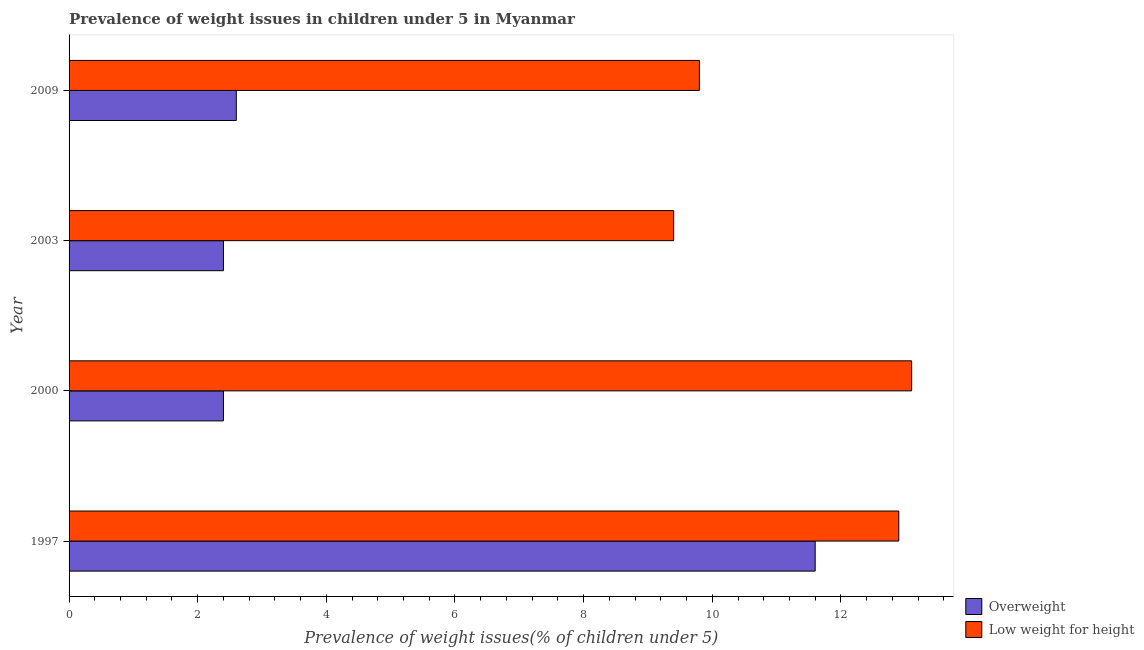How many different coloured bars are there?
Ensure brevity in your answer.  2. How many groups of bars are there?
Your response must be concise. 4. What is the label of the 4th group of bars from the top?
Keep it short and to the point. 1997. In how many cases, is the number of bars for a given year not equal to the number of legend labels?
Provide a short and direct response. 0. What is the percentage of underweight children in 2009?
Offer a very short reply. 9.8. Across all years, what is the maximum percentage of underweight children?
Your answer should be very brief. 13.1. Across all years, what is the minimum percentage of underweight children?
Make the answer very short. 9.4. In which year was the percentage of underweight children minimum?
Provide a succinct answer. 2003. What is the total percentage of overweight children in the graph?
Offer a terse response. 19. What is the difference between the percentage of overweight children in 2003 and the percentage of underweight children in 1997?
Provide a short and direct response. -10.5. What is the ratio of the percentage of underweight children in 1997 to that in 2009?
Give a very brief answer. 1.32. In how many years, is the percentage of underweight children greater than the average percentage of underweight children taken over all years?
Ensure brevity in your answer.  2. What does the 1st bar from the top in 2000 represents?
Your answer should be very brief. Low weight for height. What does the 1st bar from the bottom in 2000 represents?
Give a very brief answer. Overweight. Are all the bars in the graph horizontal?
Keep it short and to the point. Yes. Does the graph contain grids?
Your answer should be compact. No. What is the title of the graph?
Keep it short and to the point. Prevalence of weight issues in children under 5 in Myanmar. What is the label or title of the X-axis?
Your response must be concise. Prevalence of weight issues(% of children under 5). What is the label or title of the Y-axis?
Ensure brevity in your answer.  Year. What is the Prevalence of weight issues(% of children under 5) of Overweight in 1997?
Provide a succinct answer. 11.6. What is the Prevalence of weight issues(% of children under 5) of Low weight for height in 1997?
Give a very brief answer. 12.9. What is the Prevalence of weight issues(% of children under 5) of Overweight in 2000?
Your response must be concise. 2.4. What is the Prevalence of weight issues(% of children under 5) of Low weight for height in 2000?
Offer a very short reply. 13.1. What is the Prevalence of weight issues(% of children under 5) in Overweight in 2003?
Keep it short and to the point. 2.4. What is the Prevalence of weight issues(% of children under 5) of Low weight for height in 2003?
Ensure brevity in your answer.  9.4. What is the Prevalence of weight issues(% of children under 5) in Overweight in 2009?
Make the answer very short. 2.6. What is the Prevalence of weight issues(% of children under 5) in Low weight for height in 2009?
Provide a succinct answer. 9.8. Across all years, what is the maximum Prevalence of weight issues(% of children under 5) of Overweight?
Your answer should be compact. 11.6. Across all years, what is the maximum Prevalence of weight issues(% of children under 5) of Low weight for height?
Provide a short and direct response. 13.1. Across all years, what is the minimum Prevalence of weight issues(% of children under 5) in Overweight?
Your answer should be very brief. 2.4. Across all years, what is the minimum Prevalence of weight issues(% of children under 5) in Low weight for height?
Offer a very short reply. 9.4. What is the total Prevalence of weight issues(% of children under 5) in Overweight in the graph?
Your response must be concise. 19. What is the total Prevalence of weight issues(% of children under 5) in Low weight for height in the graph?
Ensure brevity in your answer.  45.2. What is the difference between the Prevalence of weight issues(% of children under 5) in Low weight for height in 1997 and that in 2003?
Keep it short and to the point. 3.5. What is the difference between the Prevalence of weight issues(% of children under 5) of Overweight in 1997 and that in 2009?
Your response must be concise. 9. What is the difference between the Prevalence of weight issues(% of children under 5) of Low weight for height in 1997 and that in 2009?
Offer a very short reply. 3.1. What is the difference between the Prevalence of weight issues(% of children under 5) of Overweight in 2000 and that in 2003?
Your answer should be compact. 0. What is the difference between the Prevalence of weight issues(% of children under 5) in Low weight for height in 2000 and that in 2003?
Ensure brevity in your answer.  3.7. What is the difference between the Prevalence of weight issues(% of children under 5) of Overweight in 2000 and that in 2009?
Make the answer very short. -0.2. What is the difference between the Prevalence of weight issues(% of children under 5) in Overweight in 1997 and the Prevalence of weight issues(% of children under 5) in Low weight for height in 2000?
Offer a very short reply. -1.5. What is the difference between the Prevalence of weight issues(% of children under 5) of Overweight in 1997 and the Prevalence of weight issues(% of children under 5) of Low weight for height in 2009?
Offer a terse response. 1.8. What is the difference between the Prevalence of weight issues(% of children under 5) in Overweight in 2000 and the Prevalence of weight issues(% of children under 5) in Low weight for height in 2003?
Your answer should be very brief. -7. What is the average Prevalence of weight issues(% of children under 5) in Overweight per year?
Make the answer very short. 4.75. What is the ratio of the Prevalence of weight issues(% of children under 5) in Overweight in 1997 to that in 2000?
Offer a terse response. 4.83. What is the ratio of the Prevalence of weight issues(% of children under 5) of Low weight for height in 1997 to that in 2000?
Provide a short and direct response. 0.98. What is the ratio of the Prevalence of weight issues(% of children under 5) in Overweight in 1997 to that in 2003?
Keep it short and to the point. 4.83. What is the ratio of the Prevalence of weight issues(% of children under 5) in Low weight for height in 1997 to that in 2003?
Offer a terse response. 1.37. What is the ratio of the Prevalence of weight issues(% of children under 5) in Overweight in 1997 to that in 2009?
Your response must be concise. 4.46. What is the ratio of the Prevalence of weight issues(% of children under 5) of Low weight for height in 1997 to that in 2009?
Your response must be concise. 1.32. What is the ratio of the Prevalence of weight issues(% of children under 5) in Low weight for height in 2000 to that in 2003?
Provide a short and direct response. 1.39. What is the ratio of the Prevalence of weight issues(% of children under 5) in Overweight in 2000 to that in 2009?
Your answer should be very brief. 0.92. What is the ratio of the Prevalence of weight issues(% of children under 5) in Low weight for height in 2000 to that in 2009?
Your answer should be compact. 1.34. What is the ratio of the Prevalence of weight issues(% of children under 5) of Overweight in 2003 to that in 2009?
Provide a short and direct response. 0.92. What is the ratio of the Prevalence of weight issues(% of children under 5) of Low weight for height in 2003 to that in 2009?
Provide a short and direct response. 0.96. What is the difference between the highest and the second highest Prevalence of weight issues(% of children under 5) in Overweight?
Make the answer very short. 9. What is the difference between the highest and the lowest Prevalence of weight issues(% of children under 5) of Overweight?
Your answer should be compact. 9.2. What is the difference between the highest and the lowest Prevalence of weight issues(% of children under 5) in Low weight for height?
Make the answer very short. 3.7. 